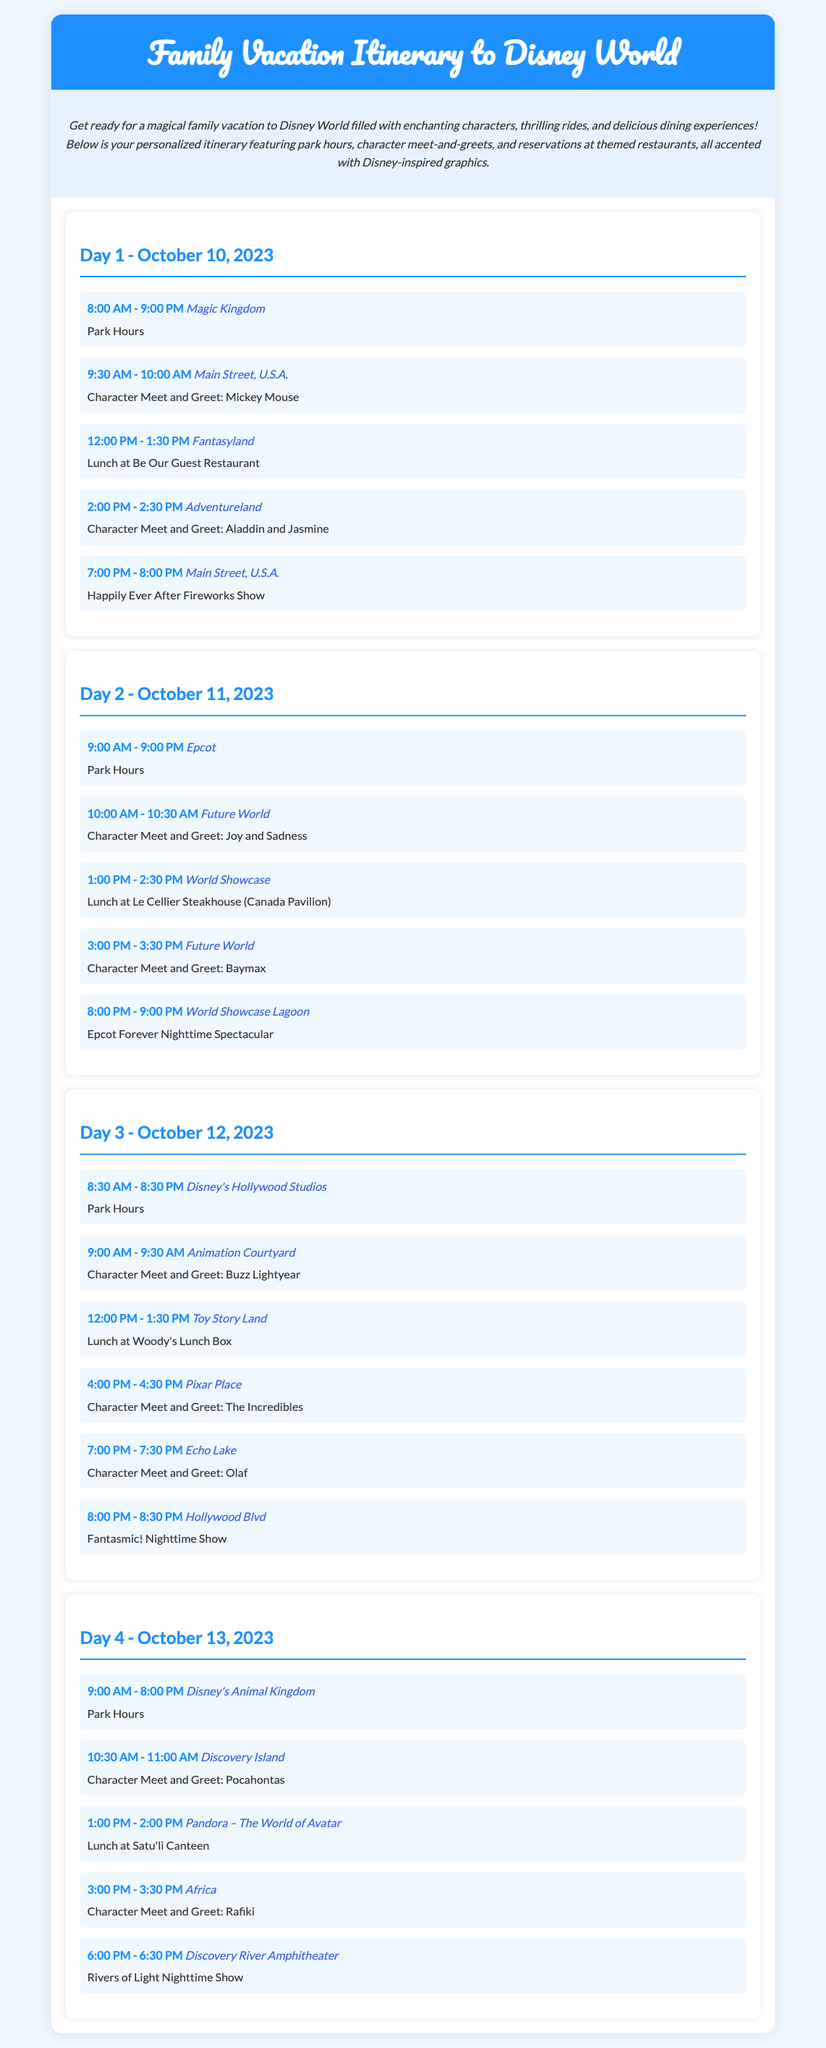what are the park hours for Magic Kingdom on Day 1? The park hours for Magic Kingdom on Day 1 are listed as 8:00 AM - 9:00 PM.
Answer: 8:00 AM - 9:00 PM who can you meet at the character meet and greet in Adventureland on Day 1? The character meet and greet in Adventureland on Day 1 features Aladdin and Jasmine.
Answer: Aladdin and Jasmine what time is lunch at Be Our Guest Restaurant on Day 1? Lunch at Be Our Guest Restaurant on Day 1 is scheduled from 12:00 PM - 1:30 PM.
Answer: 12:00 PM - 1:30 PM how many character meet and greets are scheduled on Day 3? Day 3 includes a total of four character meet and greets.
Answer: four which restaurant is reserved for lunch on Day 2? On Day 2, lunch is reserved at Le Cellier Steakhouse in the Canada Pavilion.
Answer: Le Cellier Steakhouse what is the last event listed on Day 4? The last event listed for Day 4 is the Rivers of Light Nighttime Show.
Answer: Rivers of Light Nighttime Show what is the total number of days in this itinerary? The itinerary covers a total of four days.
Answer: four which park is open from 9:00 AM - 8:00 PM on Day 4? Disney's Animal Kingdom is open from 9:00 AM - 8:00 PM on Day 4.
Answer: Disney's Animal Kingdom 